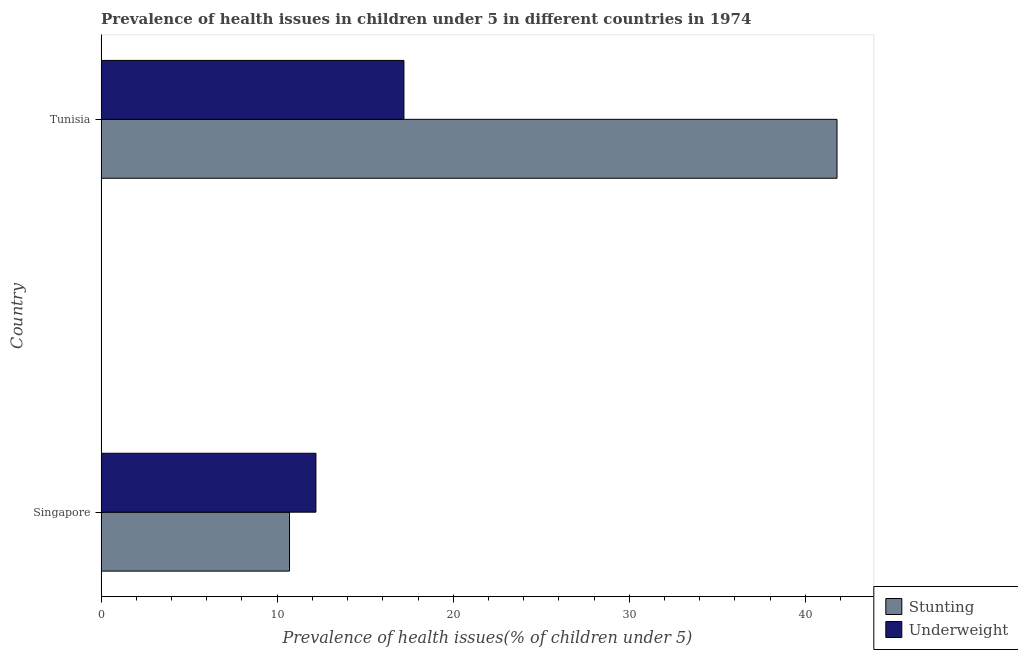Are the number of bars on each tick of the Y-axis equal?
Your answer should be compact. Yes. How many bars are there on the 2nd tick from the bottom?
Offer a terse response. 2. What is the label of the 2nd group of bars from the top?
Your response must be concise. Singapore. What is the percentage of underweight children in Singapore?
Offer a very short reply. 12.2. Across all countries, what is the maximum percentage of stunted children?
Offer a very short reply. 41.8. Across all countries, what is the minimum percentage of stunted children?
Your response must be concise. 10.7. In which country was the percentage of underweight children maximum?
Give a very brief answer. Tunisia. In which country was the percentage of underweight children minimum?
Offer a terse response. Singapore. What is the total percentage of underweight children in the graph?
Provide a succinct answer. 29.4. What is the difference between the percentage of stunted children in Singapore and that in Tunisia?
Provide a succinct answer. -31.1. What is the difference between the percentage of underweight children in Singapore and the percentage of stunted children in Tunisia?
Offer a terse response. -29.6. What is the average percentage of stunted children per country?
Your answer should be very brief. 26.25. What is the difference between the percentage of underweight children and percentage of stunted children in Singapore?
Provide a succinct answer. 1.5. In how many countries, is the percentage of stunted children greater than 16 %?
Your answer should be very brief. 1. What is the ratio of the percentage of underweight children in Singapore to that in Tunisia?
Make the answer very short. 0.71. What does the 2nd bar from the top in Singapore represents?
Your response must be concise. Stunting. What does the 1st bar from the bottom in Tunisia represents?
Your response must be concise. Stunting. How many bars are there?
Make the answer very short. 4. How many countries are there in the graph?
Offer a very short reply. 2. What is the difference between two consecutive major ticks on the X-axis?
Make the answer very short. 10. Does the graph contain any zero values?
Your answer should be compact. No. Does the graph contain grids?
Provide a succinct answer. No. Where does the legend appear in the graph?
Your answer should be compact. Bottom right. How are the legend labels stacked?
Make the answer very short. Vertical. What is the title of the graph?
Ensure brevity in your answer.  Prevalence of health issues in children under 5 in different countries in 1974. What is the label or title of the X-axis?
Offer a terse response. Prevalence of health issues(% of children under 5). What is the Prevalence of health issues(% of children under 5) in Stunting in Singapore?
Your answer should be very brief. 10.7. What is the Prevalence of health issues(% of children under 5) in Underweight in Singapore?
Make the answer very short. 12.2. What is the Prevalence of health issues(% of children under 5) of Stunting in Tunisia?
Keep it short and to the point. 41.8. What is the Prevalence of health issues(% of children under 5) in Underweight in Tunisia?
Offer a very short reply. 17.2. Across all countries, what is the maximum Prevalence of health issues(% of children under 5) in Stunting?
Provide a short and direct response. 41.8. Across all countries, what is the maximum Prevalence of health issues(% of children under 5) in Underweight?
Keep it short and to the point. 17.2. Across all countries, what is the minimum Prevalence of health issues(% of children under 5) of Stunting?
Your response must be concise. 10.7. Across all countries, what is the minimum Prevalence of health issues(% of children under 5) of Underweight?
Ensure brevity in your answer.  12.2. What is the total Prevalence of health issues(% of children under 5) of Stunting in the graph?
Make the answer very short. 52.5. What is the total Prevalence of health issues(% of children under 5) of Underweight in the graph?
Provide a short and direct response. 29.4. What is the difference between the Prevalence of health issues(% of children under 5) of Stunting in Singapore and that in Tunisia?
Ensure brevity in your answer.  -31.1. What is the difference between the Prevalence of health issues(% of children under 5) of Underweight in Singapore and that in Tunisia?
Your answer should be very brief. -5. What is the average Prevalence of health issues(% of children under 5) in Stunting per country?
Offer a very short reply. 26.25. What is the average Prevalence of health issues(% of children under 5) of Underweight per country?
Offer a very short reply. 14.7. What is the difference between the Prevalence of health issues(% of children under 5) in Stunting and Prevalence of health issues(% of children under 5) in Underweight in Tunisia?
Offer a very short reply. 24.6. What is the ratio of the Prevalence of health issues(% of children under 5) in Stunting in Singapore to that in Tunisia?
Provide a succinct answer. 0.26. What is the ratio of the Prevalence of health issues(% of children under 5) in Underweight in Singapore to that in Tunisia?
Make the answer very short. 0.71. What is the difference between the highest and the second highest Prevalence of health issues(% of children under 5) in Stunting?
Your response must be concise. 31.1. What is the difference between the highest and the second highest Prevalence of health issues(% of children under 5) of Underweight?
Ensure brevity in your answer.  5. What is the difference between the highest and the lowest Prevalence of health issues(% of children under 5) of Stunting?
Keep it short and to the point. 31.1. 